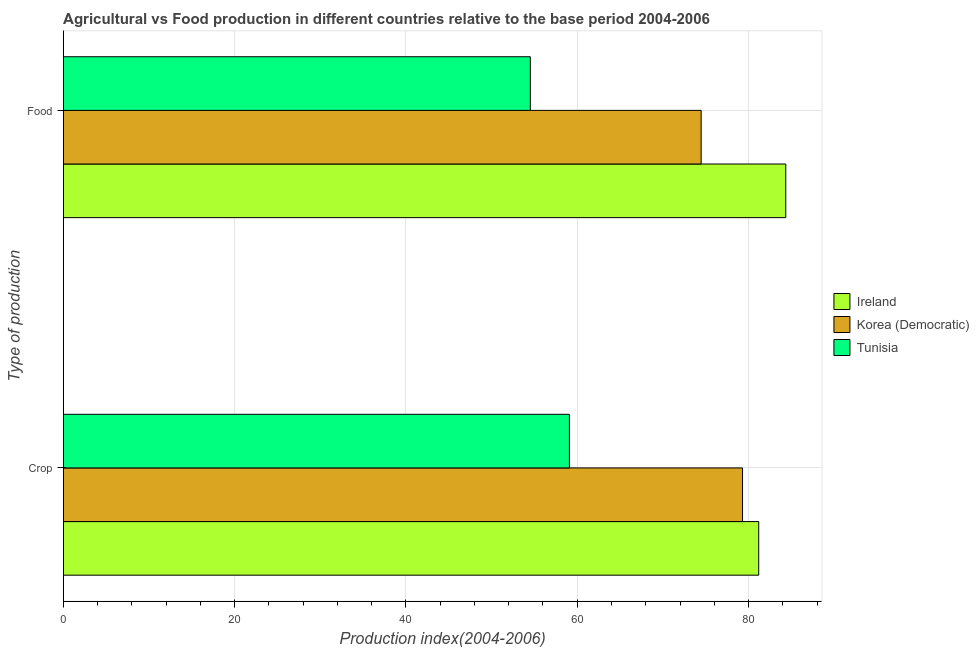How many different coloured bars are there?
Make the answer very short. 3. Are the number of bars per tick equal to the number of legend labels?
Provide a succinct answer. Yes. Are the number of bars on each tick of the Y-axis equal?
Keep it short and to the point. Yes. How many bars are there on the 1st tick from the top?
Ensure brevity in your answer.  3. What is the label of the 2nd group of bars from the top?
Your response must be concise. Crop. What is the crop production index in Ireland?
Ensure brevity in your answer.  81.19. Across all countries, what is the maximum crop production index?
Your response must be concise. 81.19. Across all countries, what is the minimum food production index?
Provide a succinct answer. 54.53. In which country was the food production index maximum?
Provide a short and direct response. Ireland. In which country was the food production index minimum?
Provide a short and direct response. Tunisia. What is the total crop production index in the graph?
Provide a succinct answer. 219.58. What is the difference between the crop production index in Tunisia and that in Ireland?
Give a very brief answer. -22.1. What is the difference between the crop production index in Korea (Democratic) and the food production index in Ireland?
Ensure brevity in your answer.  -5.05. What is the average food production index per country?
Give a very brief answer. 71.12. What is the difference between the food production index and crop production index in Tunisia?
Ensure brevity in your answer.  -4.56. What is the ratio of the food production index in Korea (Democratic) to that in Tunisia?
Your answer should be compact. 1.37. Is the food production index in Tunisia less than that in Ireland?
Offer a very short reply. Yes. In how many countries, is the crop production index greater than the average crop production index taken over all countries?
Ensure brevity in your answer.  2. What does the 3rd bar from the top in Food represents?
Give a very brief answer. Ireland. What does the 1st bar from the bottom in Crop represents?
Offer a terse response. Ireland. How many bars are there?
Your response must be concise. 6. Are all the bars in the graph horizontal?
Provide a short and direct response. Yes. Are the values on the major ticks of X-axis written in scientific E-notation?
Offer a very short reply. No. Does the graph contain any zero values?
Your answer should be compact. No. Does the graph contain grids?
Keep it short and to the point. Yes. Where does the legend appear in the graph?
Your answer should be very brief. Center right. How are the legend labels stacked?
Your response must be concise. Vertical. What is the title of the graph?
Keep it short and to the point. Agricultural vs Food production in different countries relative to the base period 2004-2006. Does "Uruguay" appear as one of the legend labels in the graph?
Make the answer very short. No. What is the label or title of the X-axis?
Ensure brevity in your answer.  Production index(2004-2006). What is the label or title of the Y-axis?
Your answer should be very brief. Type of production. What is the Production index(2004-2006) of Ireland in Crop?
Give a very brief answer. 81.19. What is the Production index(2004-2006) of Korea (Democratic) in Crop?
Provide a short and direct response. 79.3. What is the Production index(2004-2006) of Tunisia in Crop?
Make the answer very short. 59.09. What is the Production index(2004-2006) in Ireland in Food?
Make the answer very short. 84.35. What is the Production index(2004-2006) in Korea (Democratic) in Food?
Ensure brevity in your answer.  74.47. What is the Production index(2004-2006) of Tunisia in Food?
Your answer should be compact. 54.53. Across all Type of production, what is the maximum Production index(2004-2006) of Ireland?
Give a very brief answer. 84.35. Across all Type of production, what is the maximum Production index(2004-2006) of Korea (Democratic)?
Your answer should be compact. 79.3. Across all Type of production, what is the maximum Production index(2004-2006) of Tunisia?
Offer a very short reply. 59.09. Across all Type of production, what is the minimum Production index(2004-2006) of Ireland?
Provide a succinct answer. 81.19. Across all Type of production, what is the minimum Production index(2004-2006) of Korea (Democratic)?
Your answer should be very brief. 74.47. Across all Type of production, what is the minimum Production index(2004-2006) in Tunisia?
Your answer should be compact. 54.53. What is the total Production index(2004-2006) of Ireland in the graph?
Keep it short and to the point. 165.54. What is the total Production index(2004-2006) in Korea (Democratic) in the graph?
Provide a short and direct response. 153.77. What is the total Production index(2004-2006) of Tunisia in the graph?
Keep it short and to the point. 113.62. What is the difference between the Production index(2004-2006) in Ireland in Crop and that in Food?
Provide a short and direct response. -3.16. What is the difference between the Production index(2004-2006) of Korea (Democratic) in Crop and that in Food?
Your answer should be very brief. 4.83. What is the difference between the Production index(2004-2006) of Tunisia in Crop and that in Food?
Your answer should be compact. 4.56. What is the difference between the Production index(2004-2006) in Ireland in Crop and the Production index(2004-2006) in Korea (Democratic) in Food?
Make the answer very short. 6.72. What is the difference between the Production index(2004-2006) of Ireland in Crop and the Production index(2004-2006) of Tunisia in Food?
Ensure brevity in your answer.  26.66. What is the difference between the Production index(2004-2006) of Korea (Democratic) in Crop and the Production index(2004-2006) of Tunisia in Food?
Offer a very short reply. 24.77. What is the average Production index(2004-2006) of Ireland per Type of production?
Offer a terse response. 82.77. What is the average Production index(2004-2006) of Korea (Democratic) per Type of production?
Provide a succinct answer. 76.89. What is the average Production index(2004-2006) of Tunisia per Type of production?
Keep it short and to the point. 56.81. What is the difference between the Production index(2004-2006) of Ireland and Production index(2004-2006) of Korea (Democratic) in Crop?
Give a very brief answer. 1.89. What is the difference between the Production index(2004-2006) in Ireland and Production index(2004-2006) in Tunisia in Crop?
Your response must be concise. 22.1. What is the difference between the Production index(2004-2006) in Korea (Democratic) and Production index(2004-2006) in Tunisia in Crop?
Give a very brief answer. 20.21. What is the difference between the Production index(2004-2006) in Ireland and Production index(2004-2006) in Korea (Democratic) in Food?
Keep it short and to the point. 9.88. What is the difference between the Production index(2004-2006) of Ireland and Production index(2004-2006) of Tunisia in Food?
Ensure brevity in your answer.  29.82. What is the difference between the Production index(2004-2006) of Korea (Democratic) and Production index(2004-2006) of Tunisia in Food?
Give a very brief answer. 19.94. What is the ratio of the Production index(2004-2006) in Ireland in Crop to that in Food?
Your answer should be very brief. 0.96. What is the ratio of the Production index(2004-2006) in Korea (Democratic) in Crop to that in Food?
Your response must be concise. 1.06. What is the ratio of the Production index(2004-2006) of Tunisia in Crop to that in Food?
Your answer should be compact. 1.08. What is the difference between the highest and the second highest Production index(2004-2006) of Ireland?
Make the answer very short. 3.16. What is the difference between the highest and the second highest Production index(2004-2006) in Korea (Democratic)?
Offer a terse response. 4.83. What is the difference between the highest and the second highest Production index(2004-2006) in Tunisia?
Your response must be concise. 4.56. What is the difference between the highest and the lowest Production index(2004-2006) in Ireland?
Provide a succinct answer. 3.16. What is the difference between the highest and the lowest Production index(2004-2006) of Korea (Democratic)?
Give a very brief answer. 4.83. What is the difference between the highest and the lowest Production index(2004-2006) of Tunisia?
Provide a short and direct response. 4.56. 